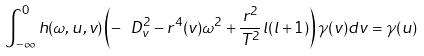<formula> <loc_0><loc_0><loc_500><loc_500>\int _ { - \infty } ^ { 0 } h ( \omega , u , v ) \left ( - \ D _ { v } ^ { 2 } - r ^ { 4 } ( v ) \omega ^ { 2 } + \frac { r ^ { 2 } } { T ^ { 2 } } l ( l + 1 ) \right ) \gamma ( v ) d v = \gamma ( u )</formula> 